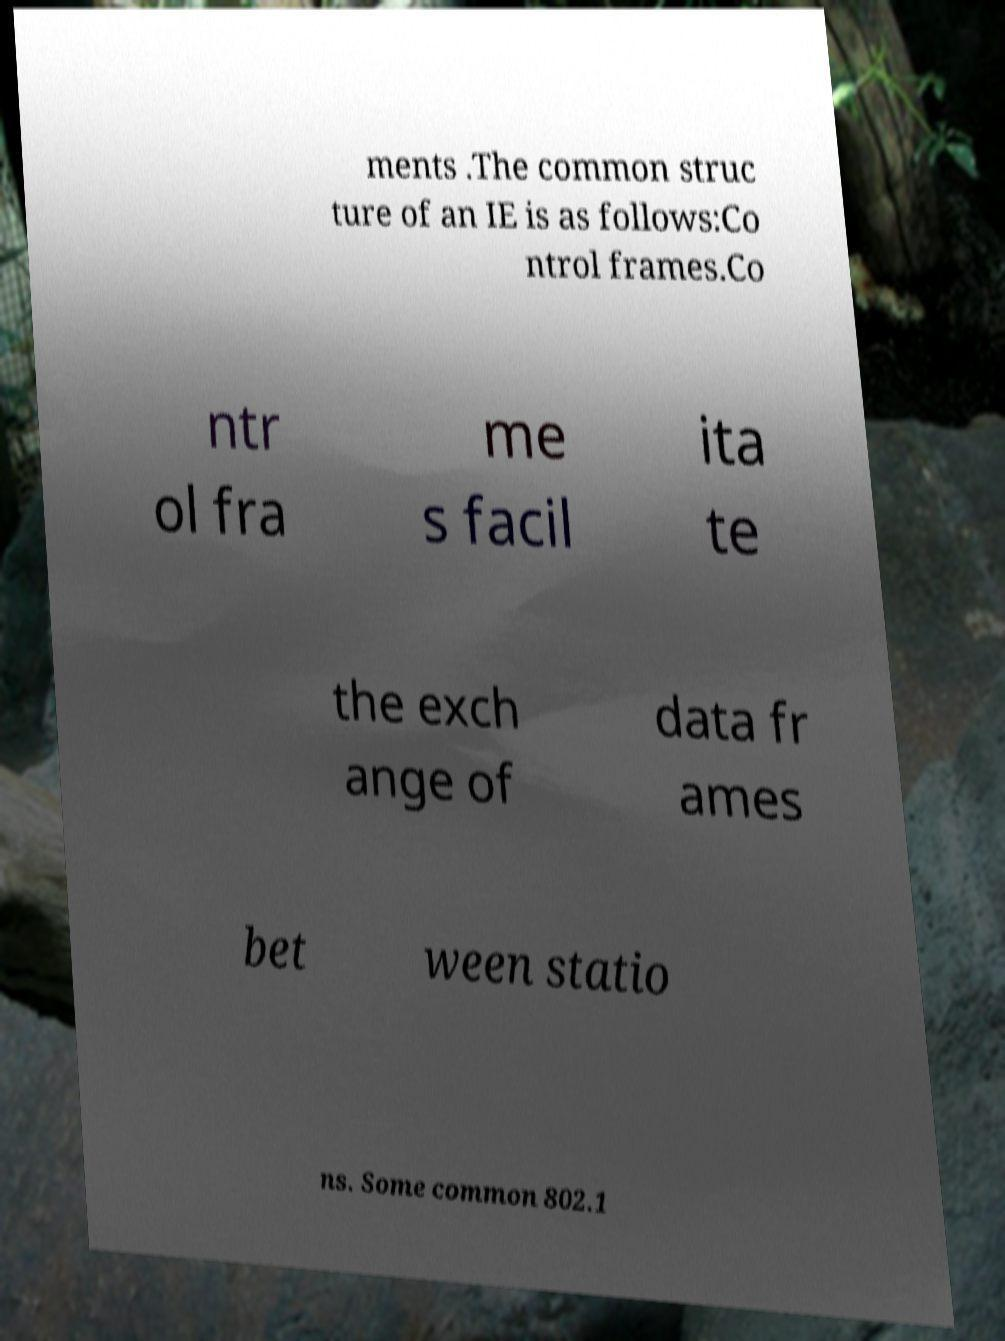I need the written content from this picture converted into text. Can you do that? ments .The common struc ture of an IE is as follows:Co ntrol frames.Co ntr ol fra me s facil ita te the exch ange of data fr ames bet ween statio ns. Some common 802.1 